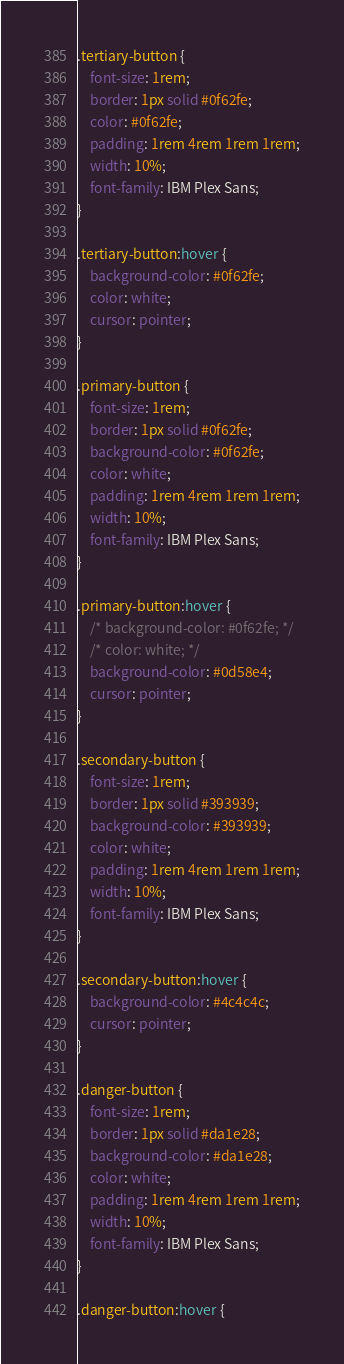Convert code to text. <code><loc_0><loc_0><loc_500><loc_500><_CSS_>.tertiary-button {
    font-size: 1rem;
    border: 1px solid #0f62fe;
    color: #0f62fe;
    padding: 1rem 4rem 1rem 1rem;
    width: 10%;
    font-family: IBM Plex Sans;
}

.tertiary-button:hover {
    background-color: #0f62fe;
    color: white;
    cursor: pointer;
}

.primary-button {
    font-size: 1rem;
    border: 1px solid #0f62fe;
    background-color: #0f62fe;
    color: white;
    padding: 1rem 4rem 1rem 1rem;
    width: 10%;
    font-family: IBM Plex Sans;
}

.primary-button:hover {
    /* background-color: #0f62fe; */
    /* color: white; */
    background-color: #0d58e4;
    cursor: pointer;
}

.secondary-button {
    font-size: 1rem;
    border: 1px solid #393939;
    background-color: #393939;
    color: white;
    padding: 1rem 4rem 1rem 1rem;
    width: 10%;
    font-family: IBM Plex Sans;
}

.secondary-button:hover {
    background-color: #4c4c4c;
    cursor: pointer;
}

.danger-button {
    font-size: 1rem;
    border: 1px solid #da1e28;
    background-color: #da1e28;
    color: white;
    padding: 1rem 4rem 1rem 1rem;
    width: 10%;
    font-family: IBM Plex Sans;
}

.danger-button:hover {</code> 